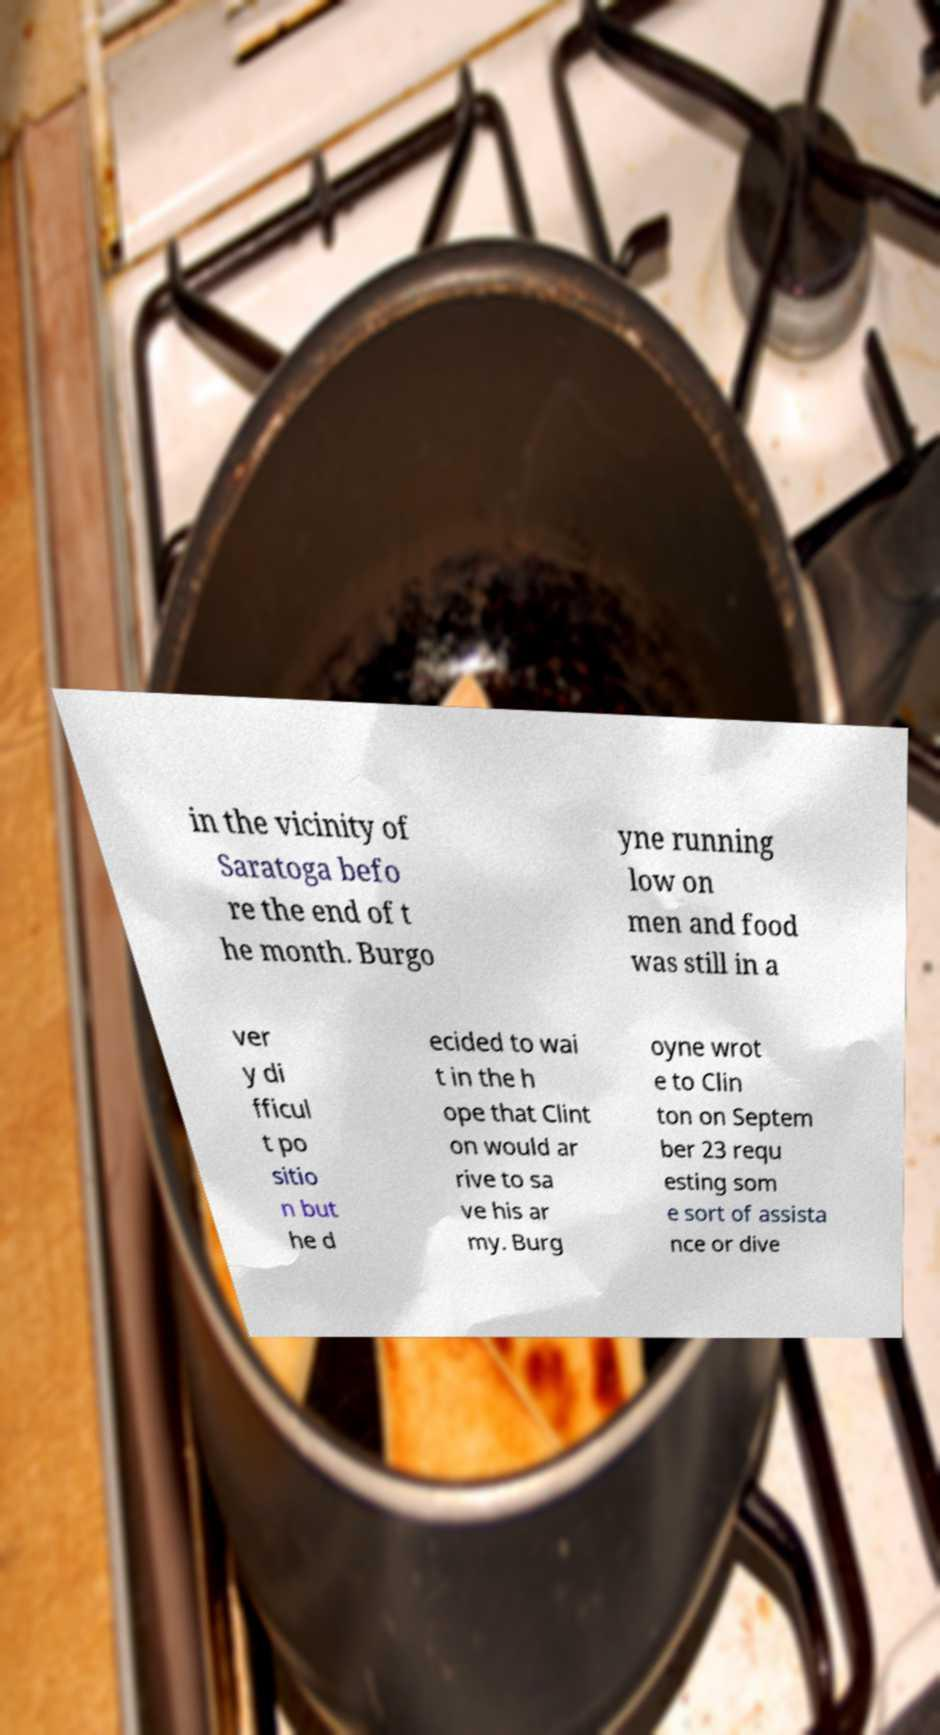For documentation purposes, I need the text within this image transcribed. Could you provide that? in the vicinity of Saratoga befo re the end of t he month. Burgo yne running low on men and food was still in a ver y di fficul t po sitio n but he d ecided to wai t in the h ope that Clint on would ar rive to sa ve his ar my. Burg oyne wrot e to Clin ton on Septem ber 23 requ esting som e sort of assista nce or dive 